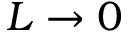Convert formula to latex. <formula><loc_0><loc_0><loc_500><loc_500>L \rightarrow 0</formula> 